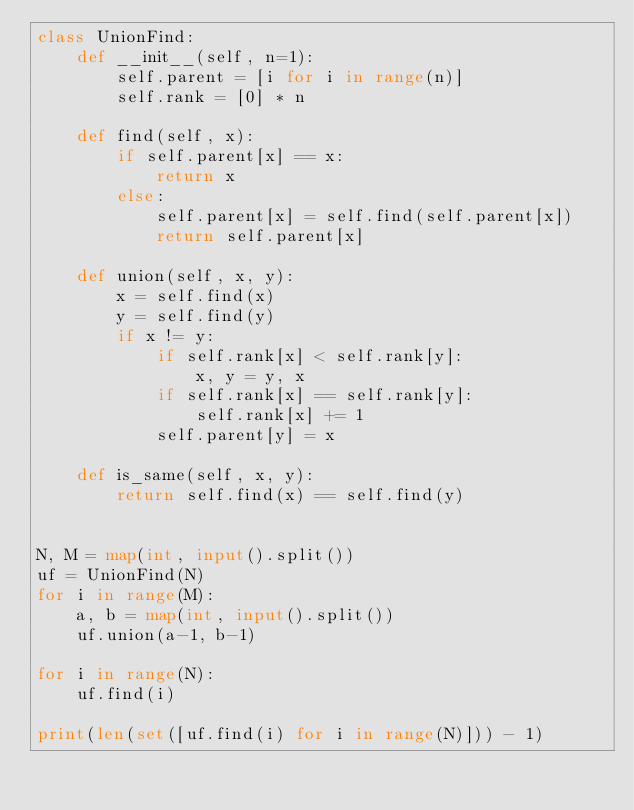<code> <loc_0><loc_0><loc_500><loc_500><_Python_>class UnionFind:
    def __init__(self, n=1):
        self.parent = [i for i in range(n)]
        self.rank = [0] * n
    
    def find(self, x):
        if self.parent[x] == x:
            return x
        else:
            self.parent[x] = self.find(self.parent[x])
            return self.parent[x]
    
    def union(self, x, y):
        x = self.find(x)
        y = self.find(y)
        if x != y:
            if self.rank[x] < self.rank[y]:
                x, y = y, x
            if self.rank[x] == self.rank[y]:
                self.rank[x] += 1
            self.parent[y] = x
    
    def is_same(self, x, y):
        return self.find(x) == self.find(y)


N, M = map(int, input().split())
uf = UnionFind(N)
for i in range(M):
    a, b = map(int, input().split())
    uf.union(a-1, b-1)

for i in range(N):
    uf.find(i)

print(len(set([uf.find(i) for i in range(N)])) - 1)</code> 